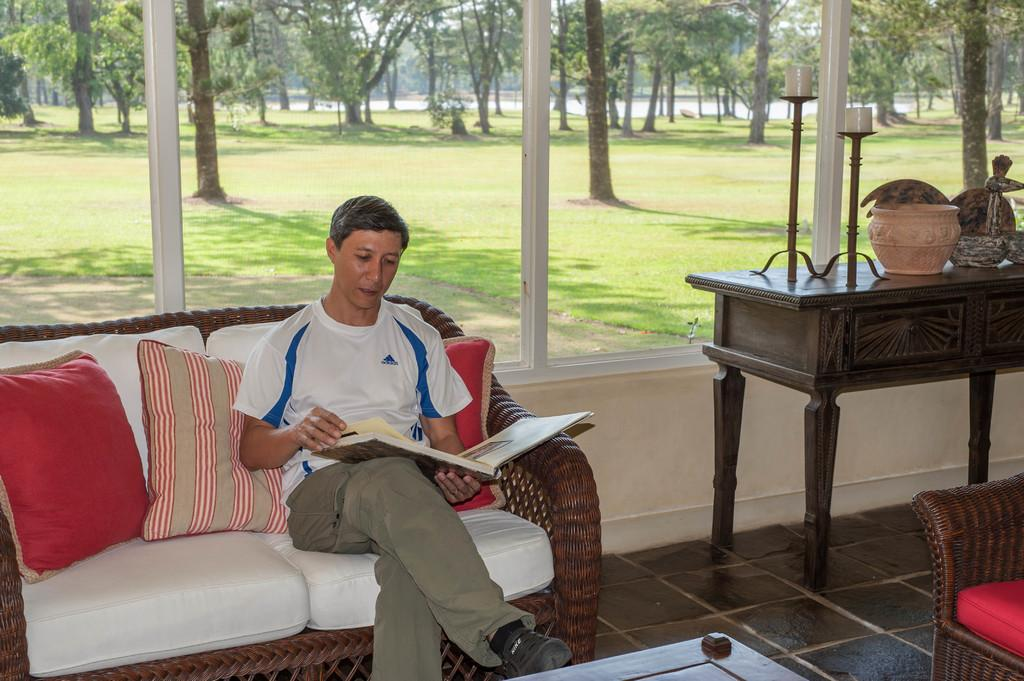What is the main subject of the image? There is a person in the image. What is the person wearing? The person is wearing a black dress. Where is the person located in the image? The person is sitting on a couch. What is the person doing in the image? The person is reading something. What can be seen in the background of the image? There are trees and a window in the background of the image. What time of day is it in the image, given that it is morning? The provided facts do not mention the time of day, and there is no indication of morning in the image. 